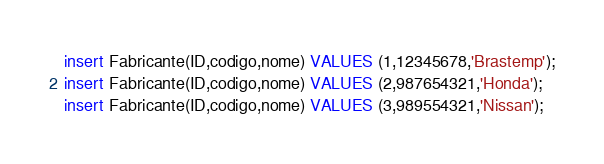Convert code to text. <code><loc_0><loc_0><loc_500><loc_500><_SQL_>
insert Fabricante(ID,codigo,nome) VALUES (1,12345678,'Brastemp');
insert Fabricante(ID,codigo,nome) VALUES (2,987654321,'Honda');
insert Fabricante(ID,codigo,nome) VALUES (3,989554321,'Nissan');
</code> 